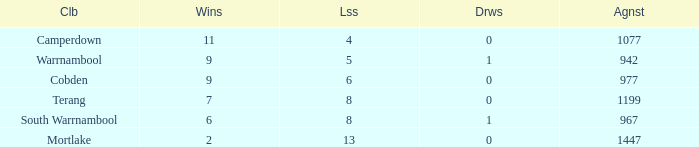How many wins did Cobden have when draws were more than 0? 0.0. 